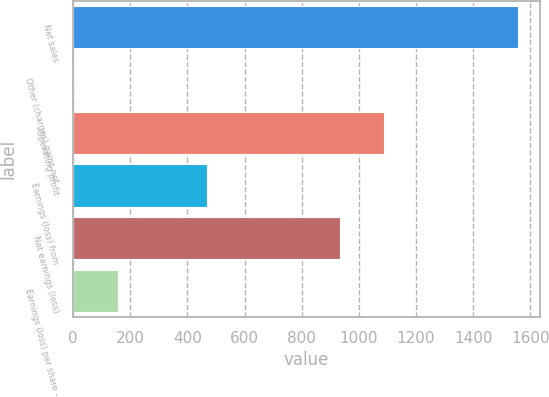<chart> <loc_0><loc_0><loc_500><loc_500><bar_chart><fcel>Net sales<fcel>Other (charges) gains net<fcel>Operating profit<fcel>Earnings (loss) from<fcel>Net earnings (loss)<fcel>Earnings (loss) per share -<nl><fcel>1555<fcel>1<fcel>1088.8<fcel>467.2<fcel>933.4<fcel>156.4<nl></chart> 